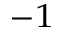Convert formula to latex. <formula><loc_0><loc_0><loc_500><loc_500>^ { - 1 }</formula> 